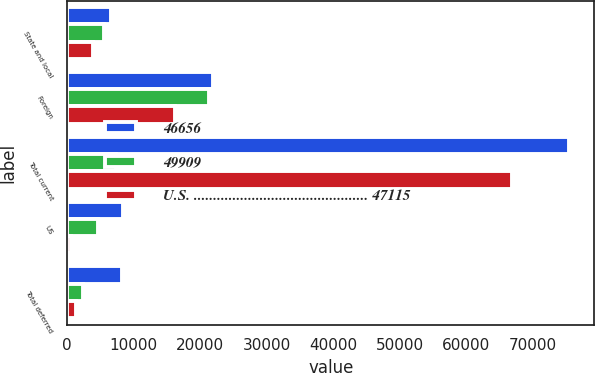<chart> <loc_0><loc_0><loc_500><loc_500><stacked_bar_chart><ecel><fcel>State and local<fcel>Foreign<fcel>Total current<fcel>US<fcel>Total deferred<nl><fcel>46656<fcel>6542<fcel>21882<fcel>75539<fcel>8366<fcel>8196<nl><fcel>49909<fcel>5522<fcel>21420<fcel>7369<fcel>4577<fcel>2449<nl><fcel>U.S. ............................................. 47115<fcel>3946<fcel>16256<fcel>66858<fcel>592<fcel>1313<nl></chart> 